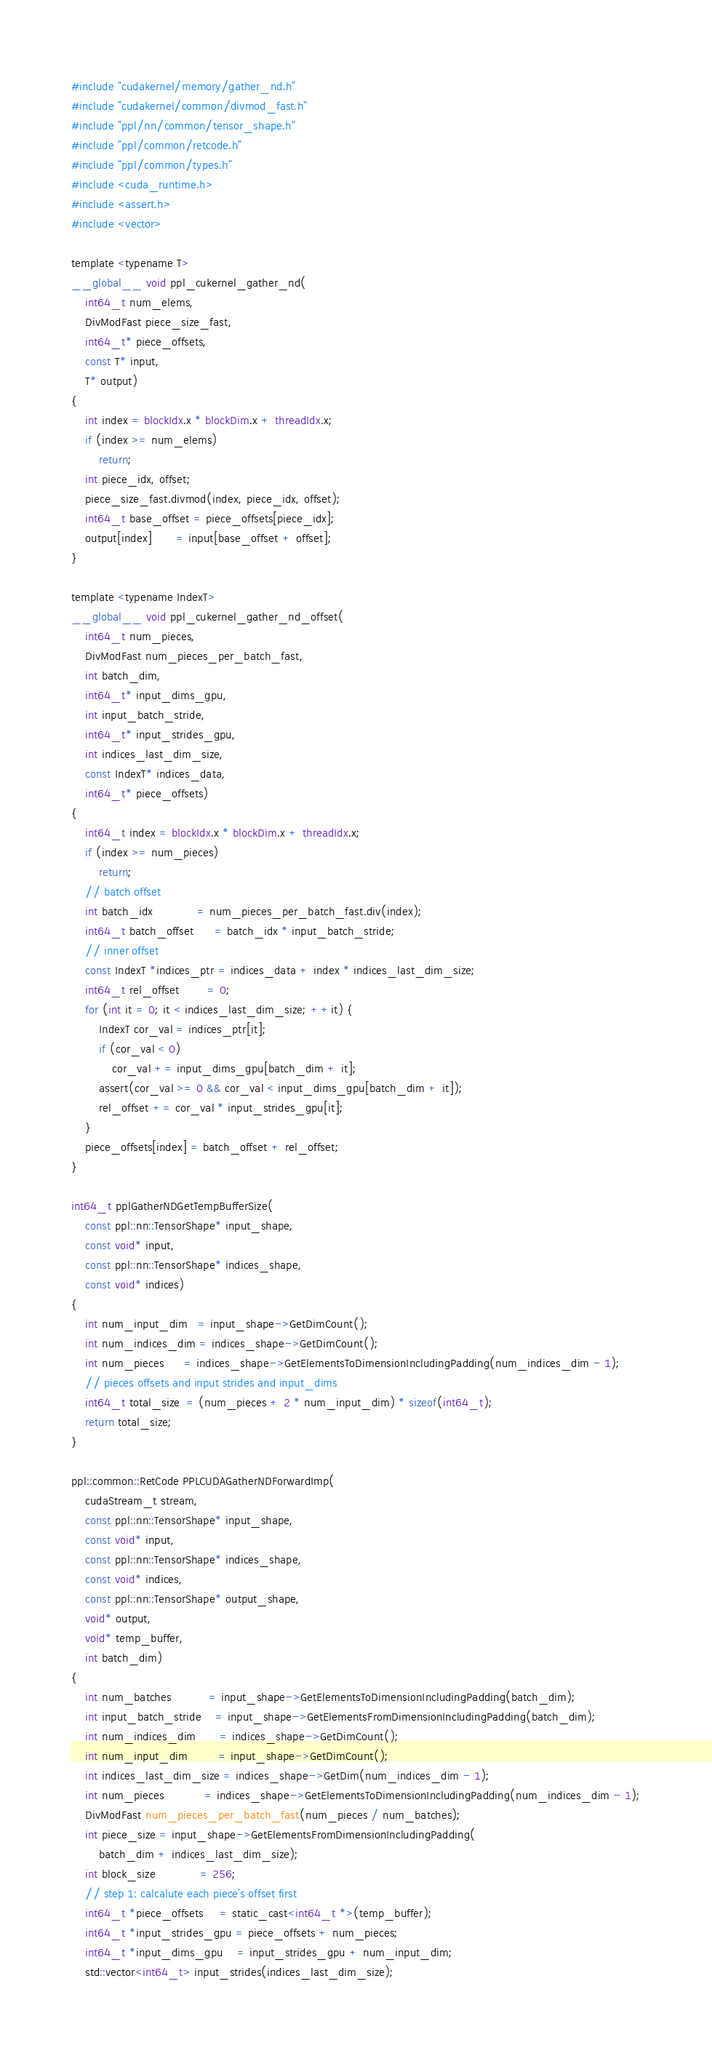Convert code to text. <code><loc_0><loc_0><loc_500><loc_500><_Cuda_>#include "cudakernel/memory/gather_nd.h"
#include "cudakernel/common/divmod_fast.h"
#include "ppl/nn/common/tensor_shape.h"
#include "ppl/common/retcode.h"
#include "ppl/common/types.h"
#include <cuda_runtime.h>
#include <assert.h>
#include <vector>

template <typename T>
__global__ void ppl_cukernel_gather_nd(
    int64_t num_elems,
    DivModFast piece_size_fast,
    int64_t* piece_offsets,
    const T* input,
    T* output)
{
    int index = blockIdx.x * blockDim.x + threadIdx.x;
    if (index >= num_elems)
        return;
    int piece_idx, offset;
    piece_size_fast.divmod(index, piece_idx, offset);
    int64_t base_offset = piece_offsets[piece_idx];
    output[index]       = input[base_offset + offset];
}

template <typename IndexT>
__global__ void ppl_cukernel_gather_nd_offset(
    int64_t num_pieces,
    DivModFast num_pieces_per_batch_fast,
    int batch_dim,
    int64_t* input_dims_gpu,
    int input_batch_stride,
    int64_t* input_strides_gpu,
    int indices_last_dim_size,
    const IndexT* indices_data,
    int64_t* piece_offsets)
{
    int64_t index = blockIdx.x * blockDim.x + threadIdx.x;
    if (index >= num_pieces)
        return;
    // batch offset
    int batch_idx             = num_pieces_per_batch_fast.div(index);
    int64_t batch_offset      = batch_idx * input_batch_stride;
    // inner offset
    const IndexT *indices_ptr = indices_data + index * indices_last_dim_size;
    int64_t rel_offset        = 0;
    for (int it = 0; it < indices_last_dim_size; ++it) {
        IndexT cor_val = indices_ptr[it];
        if (cor_val < 0)
            cor_val += input_dims_gpu[batch_dim + it];
        assert(cor_val >= 0 && cor_val < input_dims_gpu[batch_dim + it]);
        rel_offset += cor_val * input_strides_gpu[it];
    }
    piece_offsets[index] = batch_offset + rel_offset;
}

int64_t pplGatherNDGetTempBufferSize(
    const ppl::nn::TensorShape* input_shape,
    const void* input,
    const ppl::nn::TensorShape* indices_shape,
    const void* indices)
{
    int num_input_dim   = input_shape->GetDimCount();
    int num_indices_dim = indices_shape->GetDimCount();
    int num_pieces      = indices_shape->GetElementsToDimensionIncludingPadding(num_indices_dim - 1);
    // pieces offsets and input strides and input_dims
    int64_t total_size  = (num_pieces + 2 * num_input_dim) * sizeof(int64_t);
    return total_size;
}

ppl::common::RetCode PPLCUDAGatherNDForwardImp(
    cudaStream_t stream,
    const ppl::nn::TensorShape* input_shape,
    const void* input,
    const ppl::nn::TensorShape* indices_shape,
    const void* indices,
    const ppl::nn::TensorShape* output_shape,
    void* output,
    void* temp_buffer,
    int batch_dim)
{
    int num_batches           = input_shape->GetElementsToDimensionIncludingPadding(batch_dim);
    int input_batch_stride    = input_shape->GetElementsFromDimensionIncludingPadding(batch_dim);
    int num_indices_dim       = indices_shape->GetDimCount();
    int num_input_dim         = input_shape->GetDimCount();
    int indices_last_dim_size = indices_shape->GetDim(num_indices_dim - 1);
    int num_pieces            = indices_shape->GetElementsToDimensionIncludingPadding(num_indices_dim - 1);
    DivModFast num_pieces_per_batch_fast(num_pieces / num_batches);
    int piece_size = input_shape->GetElementsFromDimensionIncludingPadding(
        batch_dim + indices_last_dim_size);
    int block_size             = 256;
    // step 1: calcalute each piece's offset first
    int64_t *piece_offsets     = static_cast<int64_t *>(temp_buffer);
    int64_t *input_strides_gpu = piece_offsets + num_pieces;
    int64_t *input_dims_gpu    = input_strides_gpu + num_input_dim;
    std::vector<int64_t> input_strides(indices_last_dim_size);</code> 